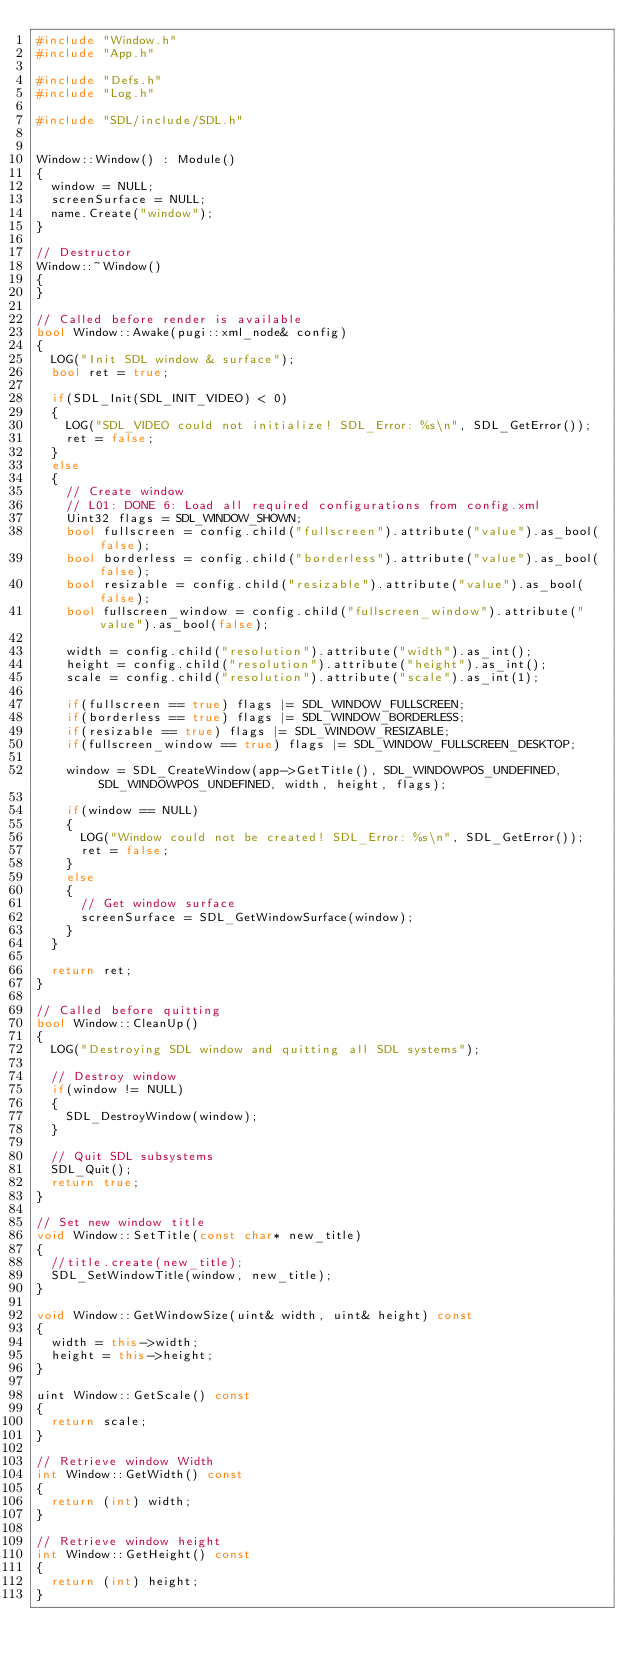Convert code to text. <code><loc_0><loc_0><loc_500><loc_500><_C++_>#include "Window.h"
#include "App.h"

#include "Defs.h"
#include "Log.h"

#include "SDL/include/SDL.h"


Window::Window() : Module()
{
	window = NULL;
	screenSurface = NULL;
	name.Create("window");
}

// Destructor
Window::~Window()
{
}

// Called before render is available
bool Window::Awake(pugi::xml_node& config)
{
	LOG("Init SDL window & surface");
	bool ret = true;

	if(SDL_Init(SDL_INIT_VIDEO) < 0)
	{
		LOG("SDL_VIDEO could not initialize! SDL_Error: %s\n", SDL_GetError());
		ret = false;
	}
	else
	{
		// Create window
		// L01: DONE 6: Load all required configurations from config.xml
		Uint32 flags = SDL_WINDOW_SHOWN;
		bool fullscreen = config.child("fullscreen").attribute("value").as_bool(false);
		bool borderless = config.child("borderless").attribute("value").as_bool(false);
		bool resizable = config.child("resizable").attribute("value").as_bool(false);
		bool fullscreen_window = config.child("fullscreen_window").attribute("value").as_bool(false);

		width = config.child("resolution").attribute("width").as_int();
		height = config.child("resolution").attribute("height").as_int();
		scale = config.child("resolution").attribute("scale").as_int(1);

		if(fullscreen == true) flags |= SDL_WINDOW_FULLSCREEN;
		if(borderless == true) flags |= SDL_WINDOW_BORDERLESS;
		if(resizable == true) flags |= SDL_WINDOW_RESIZABLE;
		if(fullscreen_window == true) flags |= SDL_WINDOW_FULLSCREEN_DESKTOP;

		window = SDL_CreateWindow(app->GetTitle(), SDL_WINDOWPOS_UNDEFINED, SDL_WINDOWPOS_UNDEFINED, width, height, flags);

		if(window == NULL)
		{
			LOG("Window could not be created! SDL_Error: %s\n", SDL_GetError());
			ret = false;
		}
		else
		{
			// Get window surface
			screenSurface = SDL_GetWindowSurface(window);
		}
	}

	return ret;
}

// Called before quitting
bool Window::CleanUp()
{
	LOG("Destroying SDL window and quitting all SDL systems");

	// Destroy window
	if(window != NULL)
	{
		SDL_DestroyWindow(window);
	}

	// Quit SDL subsystems
	SDL_Quit();
	return true;
}

// Set new window title
void Window::SetTitle(const char* new_title)
{
	//title.create(new_title);
	SDL_SetWindowTitle(window, new_title);
}

void Window::GetWindowSize(uint& width, uint& height) const
{
	width = this->width;
	height = this->height;
}

uint Window::GetScale() const
{
	return scale;
}

// Retrieve window Width
int Window::GetWidth() const
{
	return (int) width;
}

// Retrieve window height
int Window::GetHeight() const
{
	return (int) height;
}</code> 